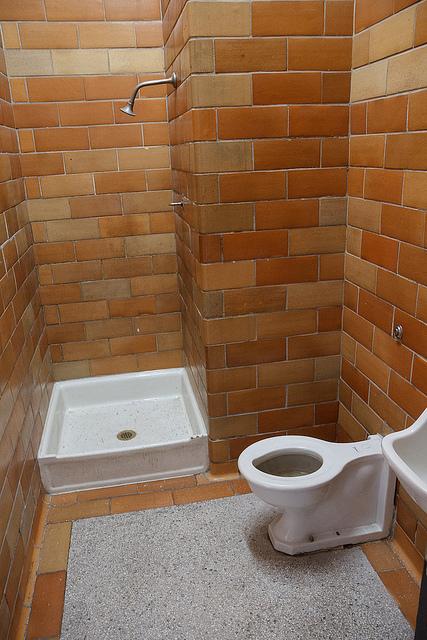Does the shower have a door?
Give a very brief answer. No. Can you use this toilet?
Short answer required. Yes. What color are the walls?
Be succinct. Brown. 